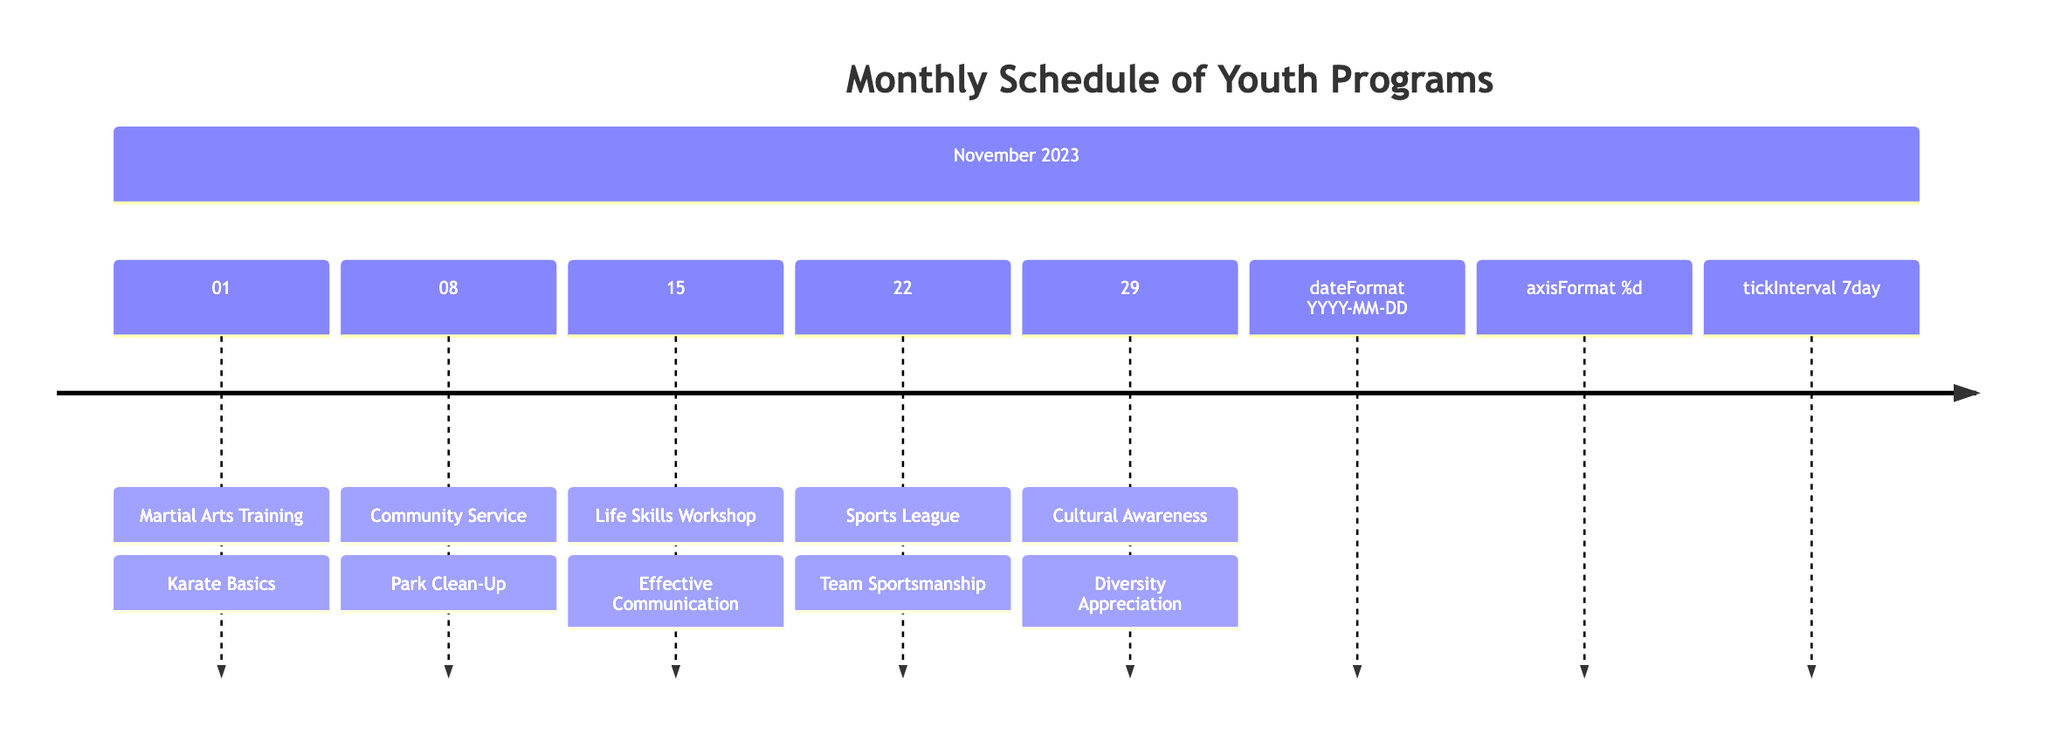What program is scheduled for November 1, 2023? The program listed for November 1, 2023, is "Martial Arts Training." This information is directly visible in the timeline.
Answer: Martial Arts Training How many programs are scheduled for November 2023? There are five programs listed for November 2023, as I can count the entries in the timeline.
Answer: 5 What activity is associated with the Community Service program? The activity listed under the Community Service program is "Park Clean-Up." This is specifically noted in the description alongside the date.
Answer: Park Clean-Up What is the focus of the Life Skills Workshop on November 15? The Life Skills Workshop on November 15 is focused on "Effective Communication," which is clearly identified in the timeline.
Answer: Effective Communication Which program emphasizes respect for different cultures? The "Cultural Awareness" program emphasizes respect for different cultures, as explicitly mentioned in its description within the timeline.
Answer: Cultural Awareness What type of activity is the Sports League program associated with? The activity associated with the Sports League program is "Team Sportsmanship," highlighting the main focus of the program directly.
Answer: Team Sportsmanship On which date is the Diversity Appreciation activity scheduled? The Diversity Appreciation activity is scheduled for November 29, 2023, as noted in the timeline next to the program.
Answer: November 29 What is the main theme of the Martial Arts Training? The main theme of the Martial Arts Training is discipline and respect, which is highlighted in its description.
Answer: Discipline and respect What does the Park Clean-Up activity teach youth about? The Park Clean-Up activity teaches youth about respect for the environment, which is stated in the description of the program.
Answer: Respect for the environment 